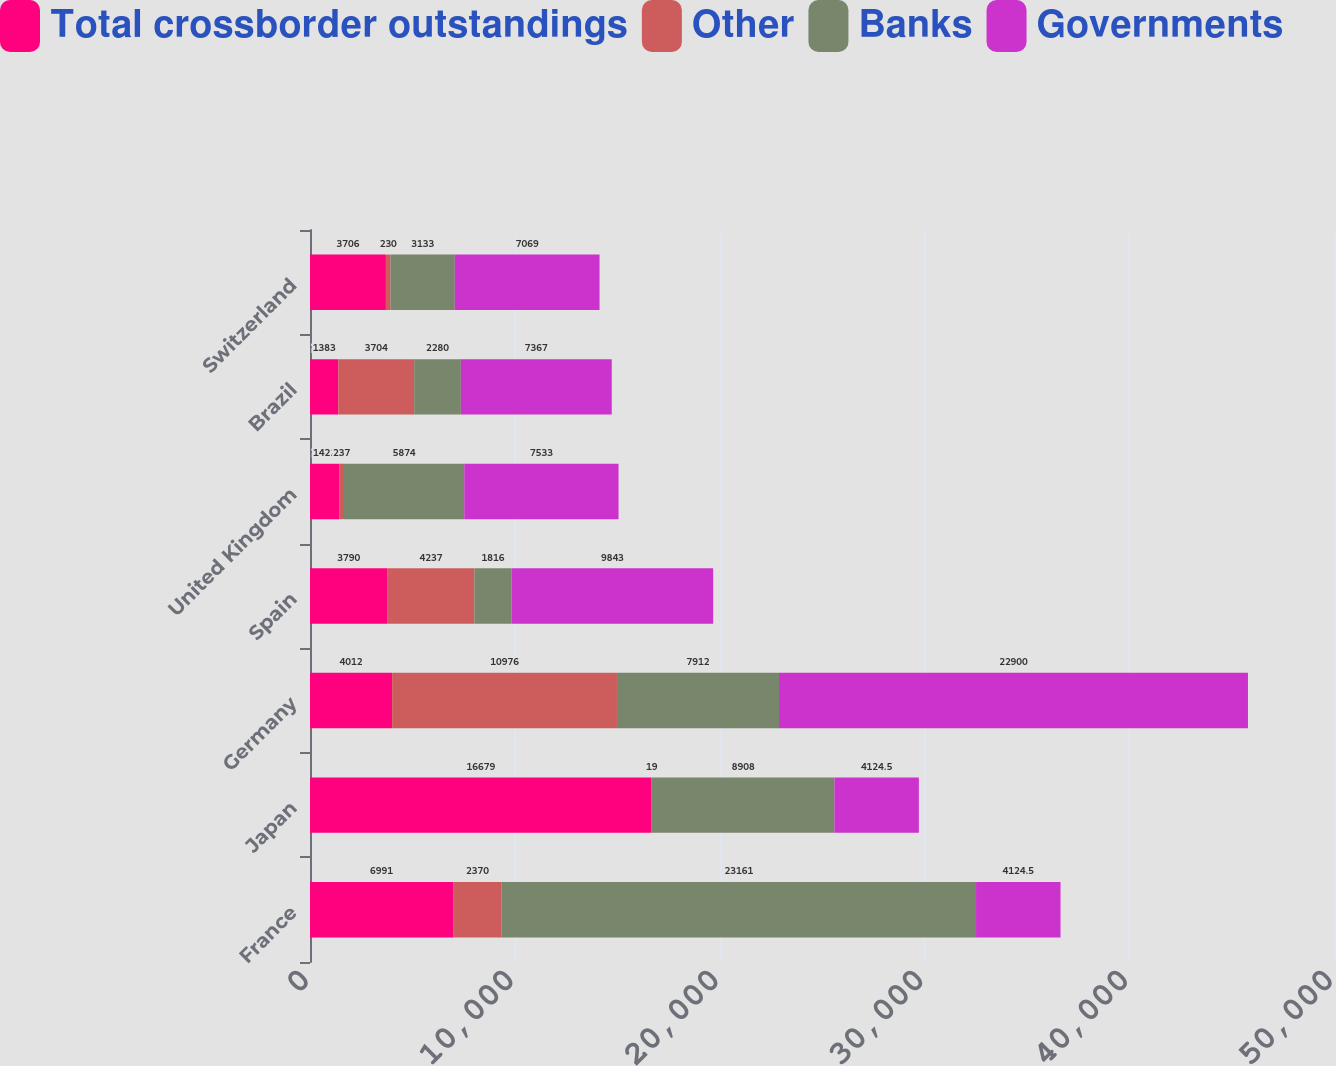Convert chart to OTSL. <chart><loc_0><loc_0><loc_500><loc_500><stacked_bar_chart><ecel><fcel>France<fcel>Japan<fcel>Germany<fcel>Spain<fcel>United Kingdom<fcel>Brazil<fcel>Switzerland<nl><fcel>Total crossborder outstandings<fcel>6991<fcel>16679<fcel>4012<fcel>3790<fcel>1422<fcel>1383<fcel>3706<nl><fcel>Other<fcel>2370<fcel>19<fcel>10976<fcel>4237<fcel>237<fcel>3704<fcel>230<nl><fcel>Banks<fcel>23161<fcel>8908<fcel>7912<fcel>1816<fcel>5874<fcel>2280<fcel>3133<nl><fcel>Governments<fcel>4124.5<fcel>4124.5<fcel>22900<fcel>9843<fcel>7533<fcel>7367<fcel>7069<nl></chart> 